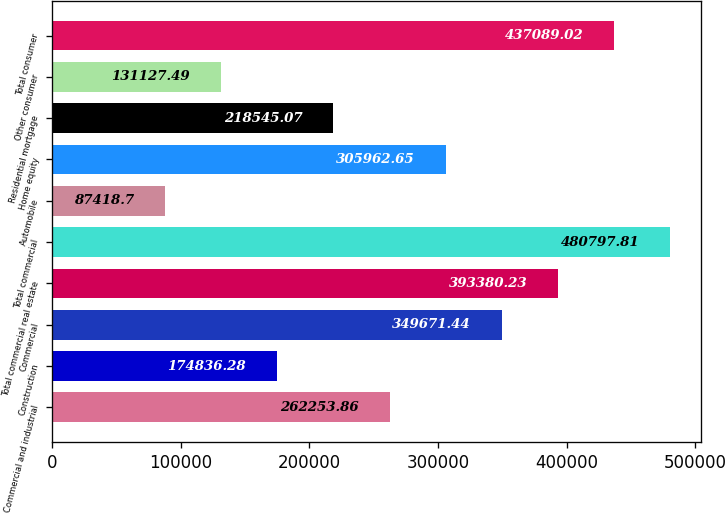<chart> <loc_0><loc_0><loc_500><loc_500><bar_chart><fcel>Commercial and industrial<fcel>Construction<fcel>Commercial<fcel>Total commercial real estate<fcel>Total commercial<fcel>Automobile<fcel>Home equity<fcel>Residential mortgage<fcel>Other consumer<fcel>Total consumer<nl><fcel>262254<fcel>174836<fcel>349671<fcel>393380<fcel>480798<fcel>87418.7<fcel>305963<fcel>218545<fcel>131127<fcel>437089<nl></chart> 